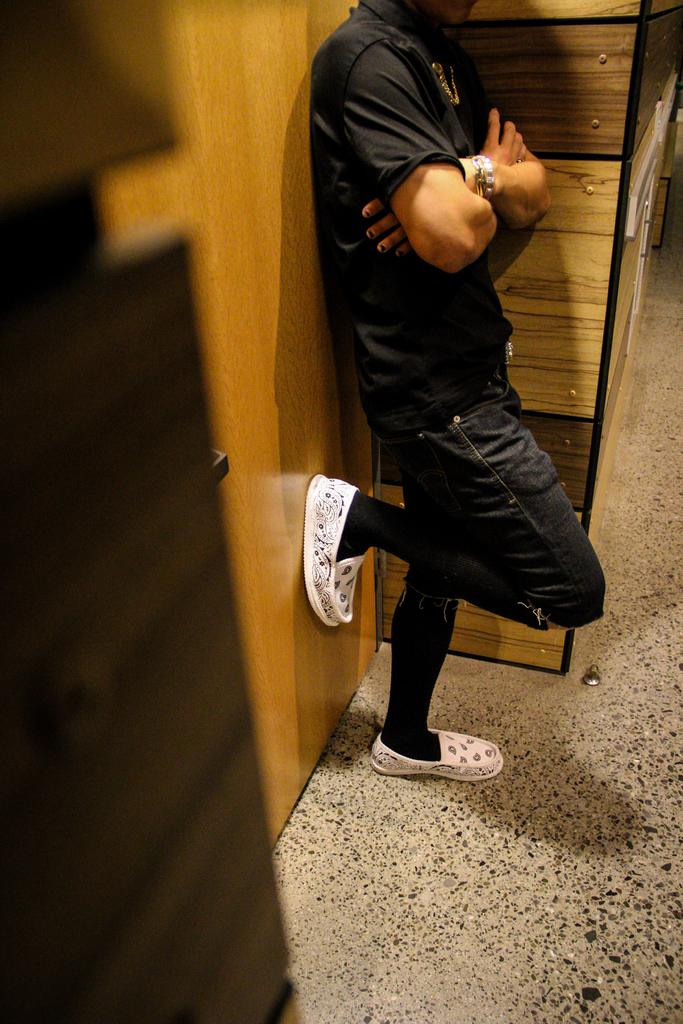What is the main subject of the image? There is a person in the image. What is the person wearing? The person is wearing a black t-shirt. What is the person doing in the image? The person is standing on one leg and has one leg on a wooden wall. Where is the wooden wall located in relation to the cupboard? The wooden wall is near a cupboard. How many cupboards can be seen in the image? There are two cupboards visible in the image. What type of animal can be seen interacting with the cupboard in the image? There are no animals present in the image; it features a person standing on one leg with one leg on a wooden wall. What is the form of the acoustics in the room depicted in the image? The image does not provide information about the acoustics in the room, so it cannot be determined from the image. 